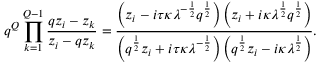<formula> <loc_0><loc_0><loc_500><loc_500>q ^ { Q } \prod _ { k = 1 } ^ { Q - 1 } \frac { q z _ { i } - z _ { k } } { z _ { i } - q z _ { k } } = \frac { \left ( z _ { i } - i \tau \kappa \lambda ^ { - \frac { 1 } { 2 } } q ^ { \frac { 1 } { 2 } } \right ) \left ( z _ { i } + i \kappa \lambda ^ { \frac { 1 } { 2 } } q ^ { \frac { 1 } { 2 } } \right ) } { \left ( q ^ { \frac { 1 } { 2 } } z _ { i } + i \tau \kappa \lambda ^ { - \frac { 1 } { 2 } } \right ) \left ( q ^ { \frac { 1 } { 2 } } z _ { i } - i \kappa \lambda ^ { \frac { 1 } { 2 } } \right ) } .</formula> 